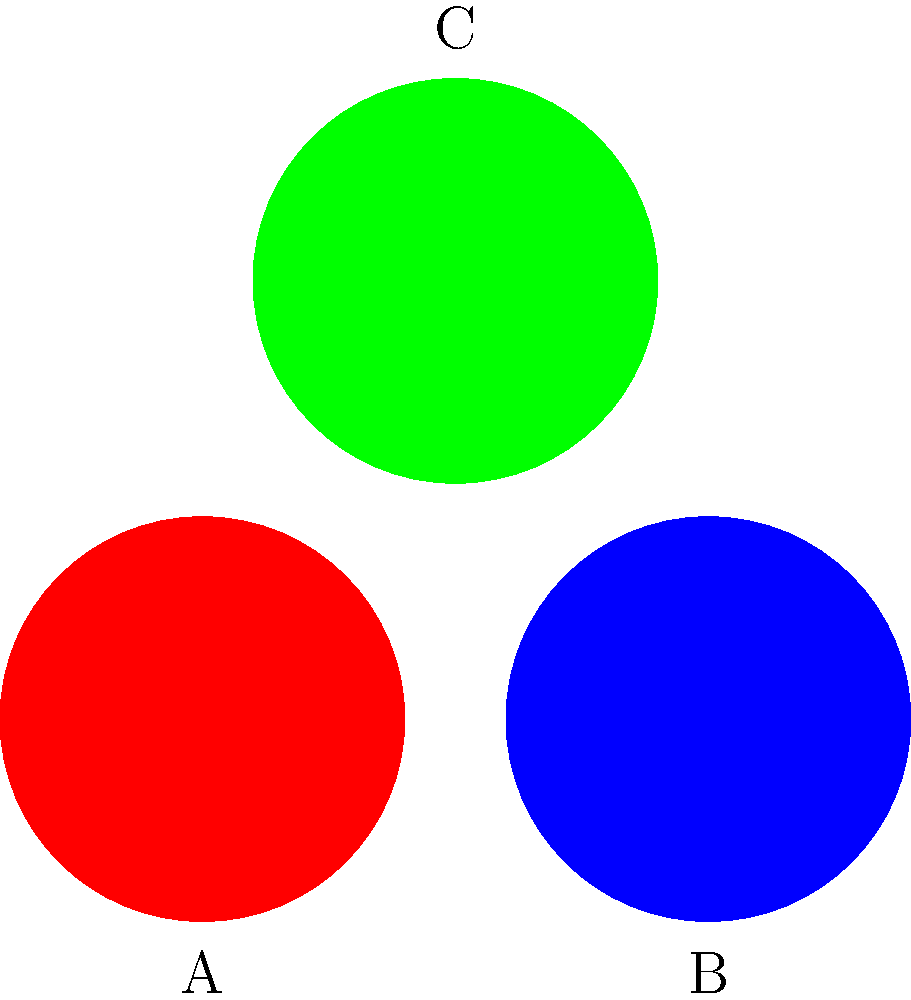In a political image recognition system, you're tasked with classifying party logos. The system uses a convolutional neural network (CNN) to extract features from the images. Given the three party logos above, which color combination would likely require the most complex feature extraction process for accurate classification? To answer this question, we need to consider the complexity of distinguishing between different colors in image recognition systems. Let's break it down step-by-step:

1. Color perception in CNNs:
   CNNs typically process images in RGB (Red, Green, Blue) color space.

2. Analyzing the given logos:
   A: Red
   B: Blue
   C: Green

3. Color distinctiveness:
   Red, Blue, and Green are primary colors and are generally easy for CNNs to distinguish.

4. Potential challenges:
   - Lighting conditions can affect color perception.
   - Similar shades of different colors might be challenging to differentiate.

5. Complexity analysis:
   In this case, all three colors are primary and distinct, so they should be relatively easy to classify.

6. Most complex combination:
   If we had to choose the most "complex" combination, it would be Red and Green. This is because:
   - Red and Green are complementary colors.
   - Some forms of color blindness affect Red-Green perception, which might be reflected in some AI models.
   - In certain lighting conditions, Red and Green might appear more similar than other combinations.

Therefore, while all colors are distinct, the Red-Green combination (A and C) might require slightly more complex feature extraction for robust classification across various conditions.
Answer: Red and Green (A and C) 